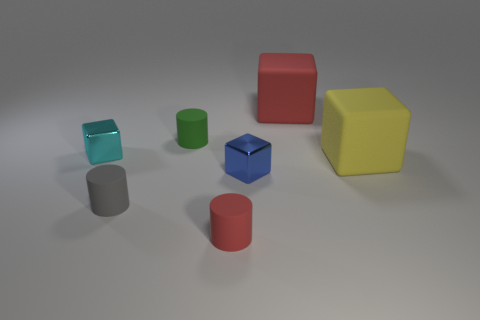Add 2 big brown shiny blocks. How many objects exist? 9 Subtract all blocks. How many objects are left? 3 Add 2 tiny purple balls. How many tiny purple balls exist? 2 Subtract 1 red cylinders. How many objects are left? 6 Subtract all tiny gray rubber cylinders. Subtract all large yellow rubber cubes. How many objects are left? 5 Add 7 large red matte things. How many large red matte things are left? 8 